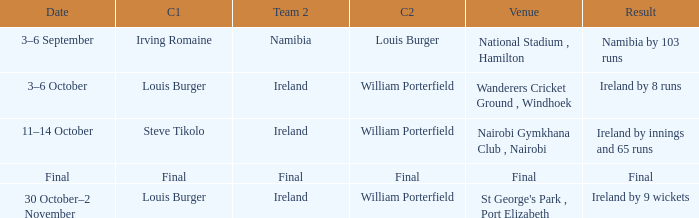Which Team 2 has a Captain 1 of final? Final. 